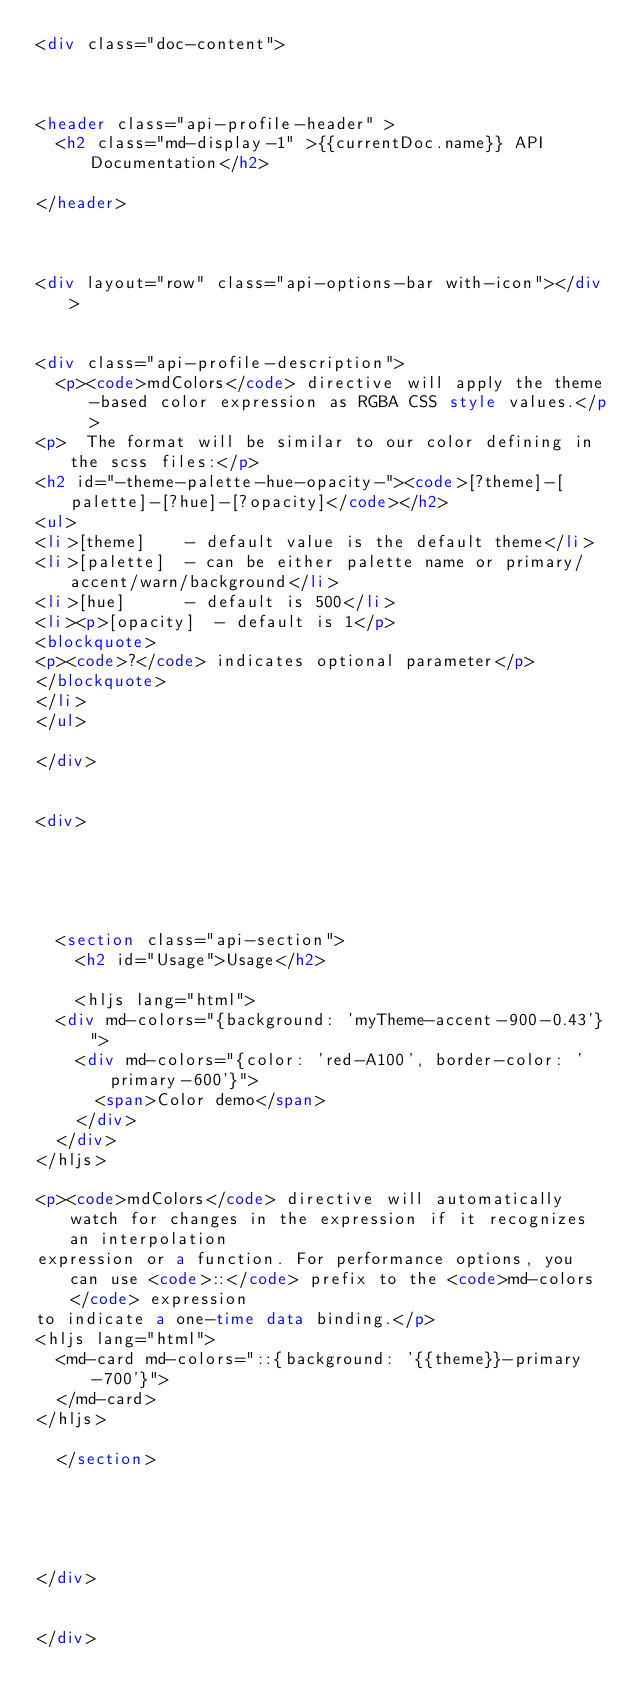<code> <loc_0><loc_0><loc_500><loc_500><_HTML_><div class="doc-content">



<header class="api-profile-header" >
  <h2 class="md-display-1" >{{currentDoc.name}} API Documentation</h2>
  
</header>



<div layout="row" class="api-options-bar with-icon"></div>


<div class="api-profile-description">
  <p><code>mdColors</code> directive will apply the theme-based color expression as RGBA CSS style values.</p>
<p>  The format will be similar to our color defining in the scss files:</p>
<h2 id="-theme-palette-hue-opacity-"><code>[?theme]-[palette]-[?hue]-[?opacity]</code></h2>
<ul>
<li>[theme]    - default value is the default theme</li>
<li>[palette]  - can be either palette name or primary/accent/warn/background</li>
<li>[hue]      - default is 500</li>
<li><p>[opacity]  - default is 1</p>
<blockquote>
<p><code>?</code> indicates optional parameter</p>
</blockquote>
</li>
</ul>

</div>


<div>
  

  

  
  <section class="api-section">
    <h2 id="Usage">Usage</h2>
  
    <hljs lang="html">
  <div md-colors="{background: 'myTheme-accent-900-0.43'}">
    <div md-colors="{color: 'red-A100', border-color: 'primary-600'}">
      <span>Color demo</span>
    </div>
  </div>
</hljs>

<p><code>mdColors</code> directive will automatically watch for changes in the expression if it recognizes an interpolation
expression or a function. For performance options, you can use <code>::</code> prefix to the <code>md-colors</code> expression
to indicate a one-time data binding.</p>
<hljs lang="html">
  <md-card md-colors="::{background: '{{theme}}-primary-700'}">
  </md-card>
</hljs>
  
  </section>
  
  


  
</div>


</div>
</code> 